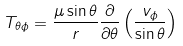Convert formula to latex. <formula><loc_0><loc_0><loc_500><loc_500>T _ { \theta \phi } = \frac { \mu \sin \theta } { r } \frac { \partial } { \partial \theta } \left ( \frac { v _ { \phi } } { \sin \theta } \right )</formula> 